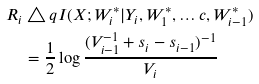<formula> <loc_0><loc_0><loc_500><loc_500>R _ { i } & \triangle q I ( X ; W _ { i } ^ { * } | Y _ { i } , W _ { 1 } ^ { * } , \dots c , W _ { i - 1 } ^ { * } ) \\ & = \frac { 1 } { 2 } \log \frac { ( V _ { i - 1 } ^ { - 1 } + s _ { i } - s _ { i - 1 } ) ^ { - 1 } } { V _ { i } }</formula> 